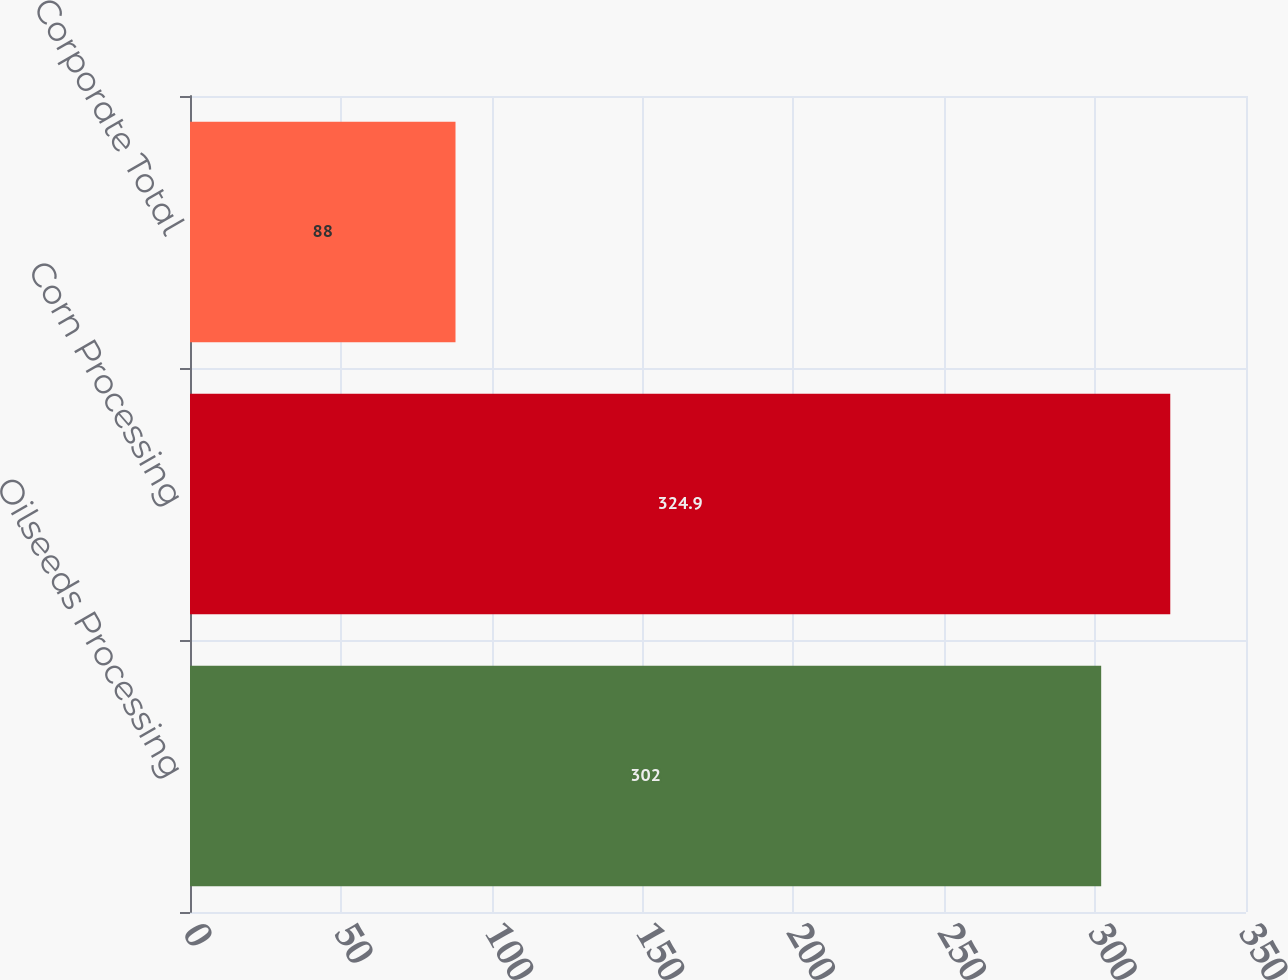<chart> <loc_0><loc_0><loc_500><loc_500><bar_chart><fcel>Oilseeds Processing<fcel>Corn Processing<fcel>Corporate Total<nl><fcel>302<fcel>324.9<fcel>88<nl></chart> 